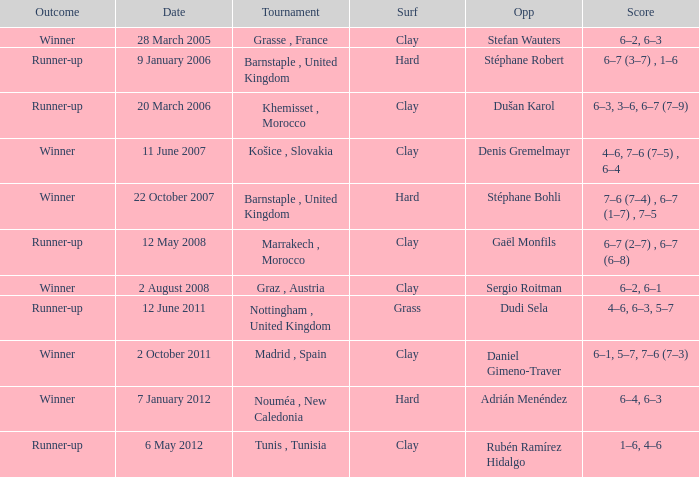What is the surface of the tournament with a runner-up outcome and dudi sela as the opponent? Grass. 